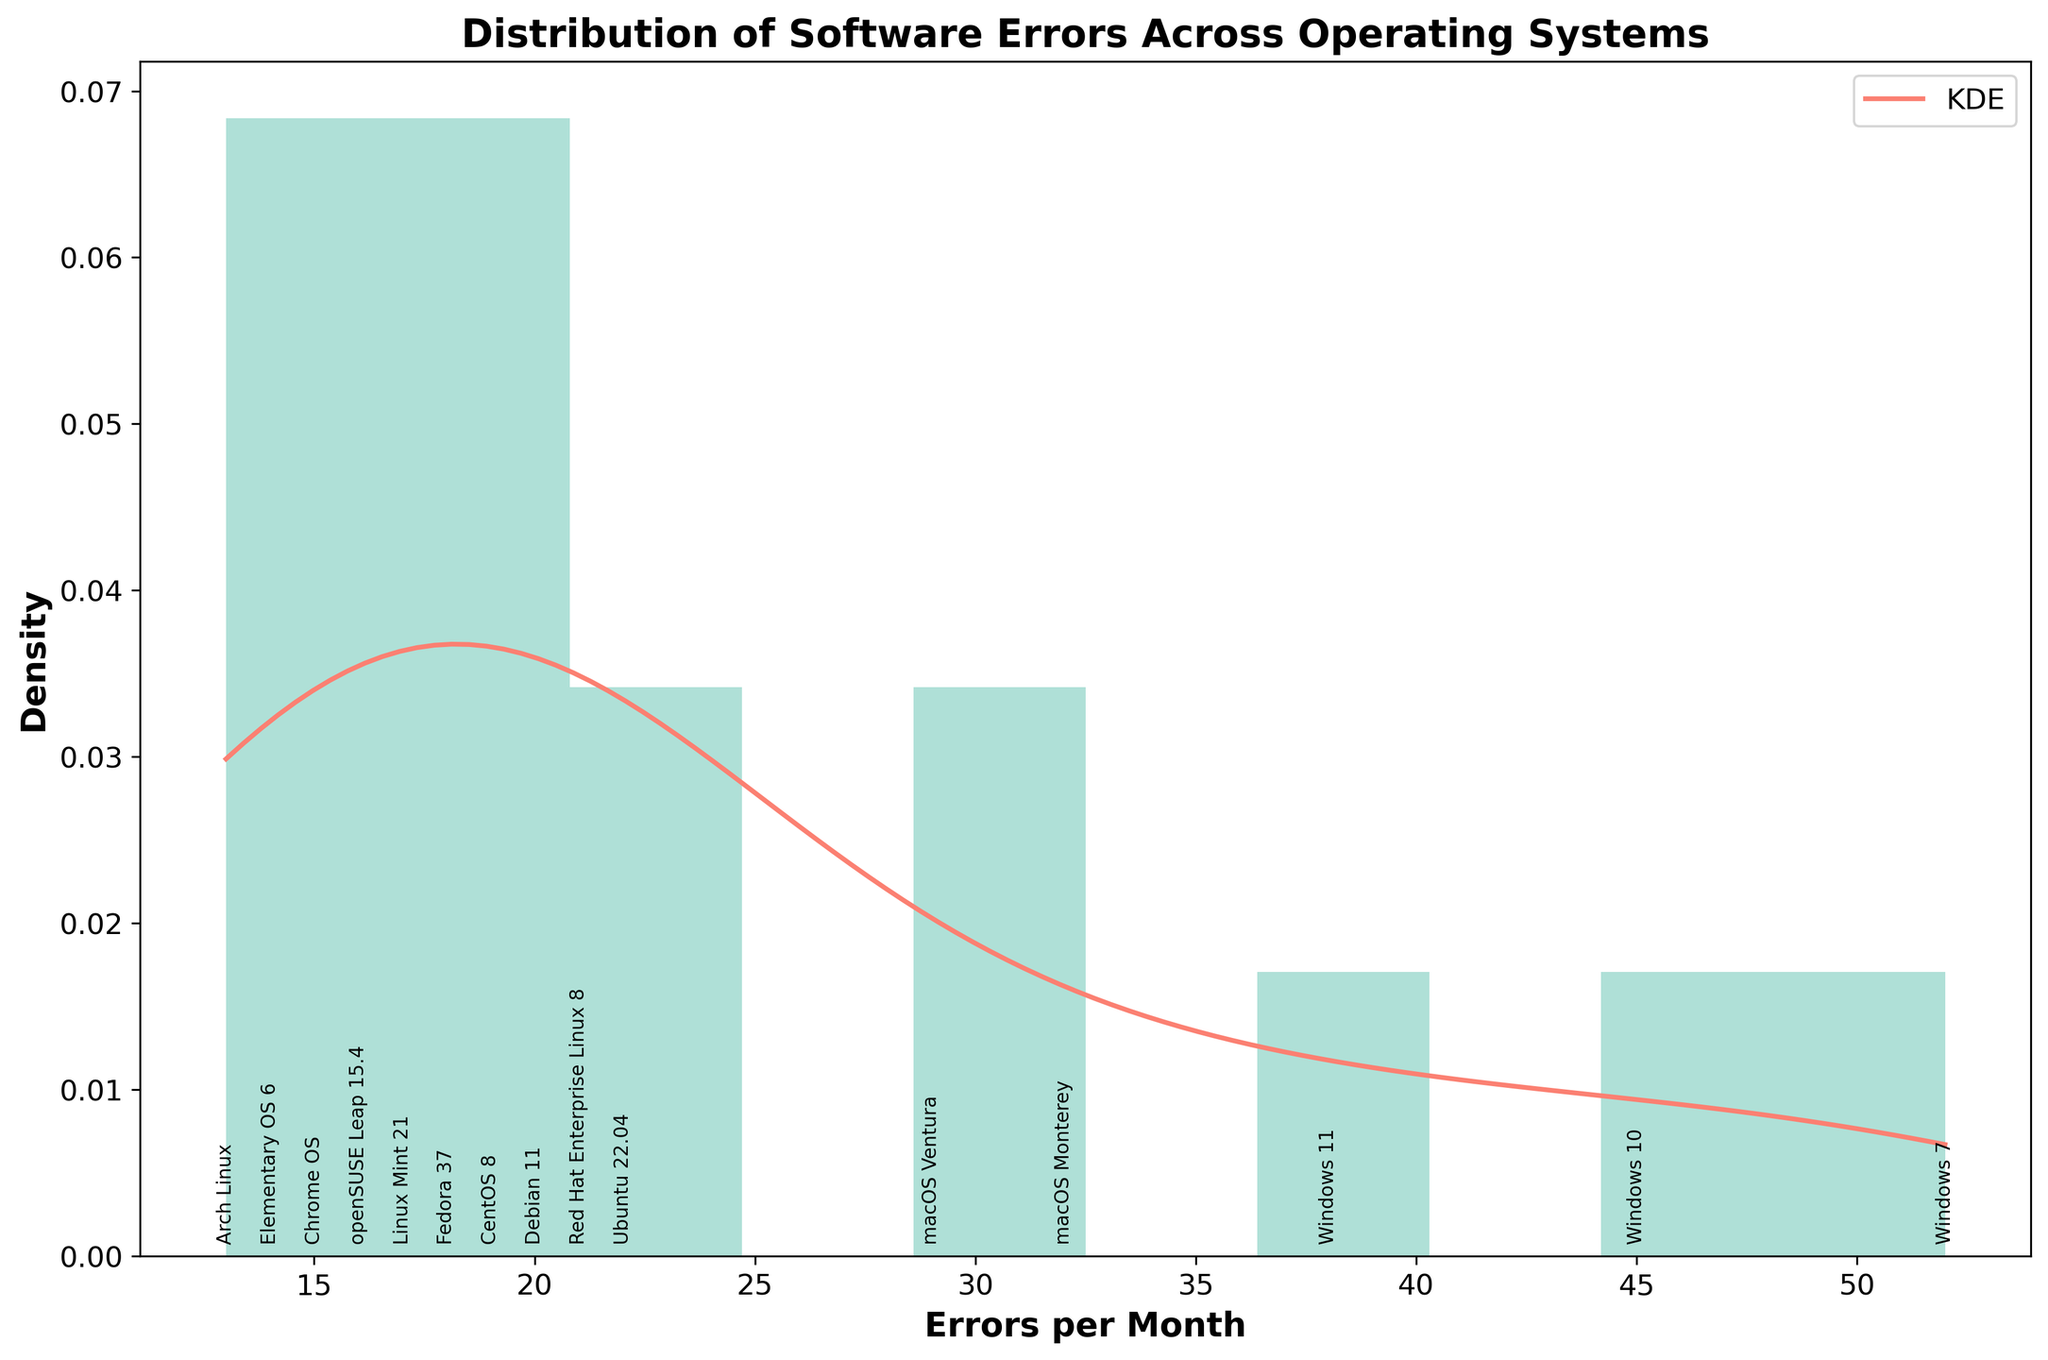What is the title of the plot? The title is located at the top of the plot and usually summarizes what the plot is about. In this case, it's easy to identify the title as it is the only prominent text at the top.
Answer: Distribution of Software Errors Across Operating Systems What does the x-axis represent? The x-axis label is usually found at the bottom of the plot, indicating what data the axis represents. Here, it is labeled with 'Errors per Month'.
Answer: Errors per Month What color is used for the histogram bars? The color of the histogram bars is visually distinguishable and can be identified by looking at the plot. The bars are filled with a light turquoise color.
Answer: Light turquoise Which operating system encountered the most software errors per month? You can determine the operating system with the highest errors per month by identifying the tallest text label along the x-axis. 'Windows 7' has the highest label placement.
Answer: Windows 7 What is the KDE curve's color? The KDE curve is the smooth line overlaid on the histogram and can be identified by its distinct color, which is a reddish-pink.
Answer: Reddish-pink How many operating systems are represented in the histogram? Each unique label along the x-axis represents an operating system, and a count of these labels indicates the total number of operating systems. There are 15 labels in total.
Answer: 15 What is the range of the x-axis? The range of the x-axis can be determined by looking at its minimum and maximum values. Here, the minimum is around 10 and the maximum is around 55.
Answer: ~10 to ~55 Which operating systems have less than 20 errors per month? By looking at the labels along the x-axis that are positioned below the 20 errors per month mark, we can identify these operating systems: 'Elementary OS 6', 'Chrome OS', 'Arch Linux', 'openSUSE Leap 15.4', 'Linux Mint 21', 'Fedora 37', and 'Debian 11'.
Answer: Elementary OS 6, Chrome OS, Arch Linux, openSUSE Leap 15.4, Linux Mint 21, Fedora 37, Debian 11 What is the value range of most frequent errors according to the KDE curve? The KDE curve peaks around the areas where errors per month are most frequent. From the plot, it is seen that the peak of the KDE curve occurs roughly between 35 to 45 errors per month.
Answer: 35 to 45 errors per month How does the KDE curve help in understanding the error distribution compared to just the histogram? The KDE curve provides a smooth estimate of the probability density function of the dataset, highlighting peaks and patterns more clearly than the histogram alone. This helps in identifying where the majority of the data points are concentrated and how they are distributed across the range of values.
Answer: Highlights peaks and patterns more clearly 